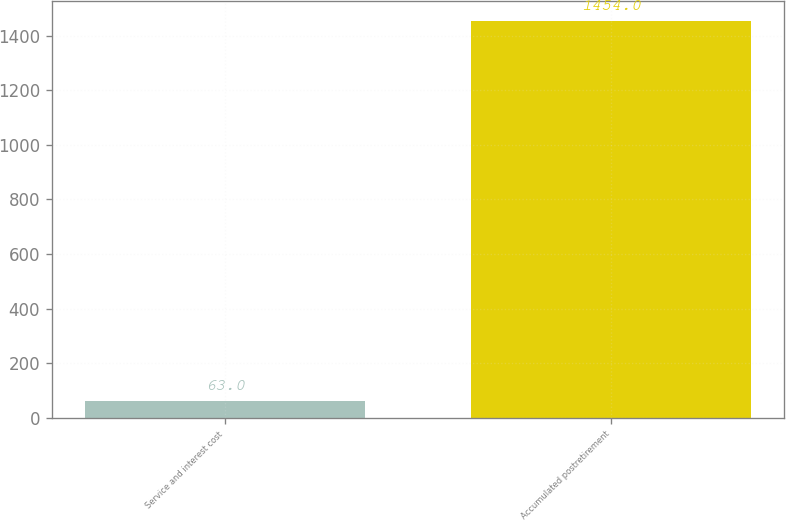Convert chart. <chart><loc_0><loc_0><loc_500><loc_500><bar_chart><fcel>Service and interest cost<fcel>Accumulated postretirement<nl><fcel>63<fcel>1454<nl></chart> 